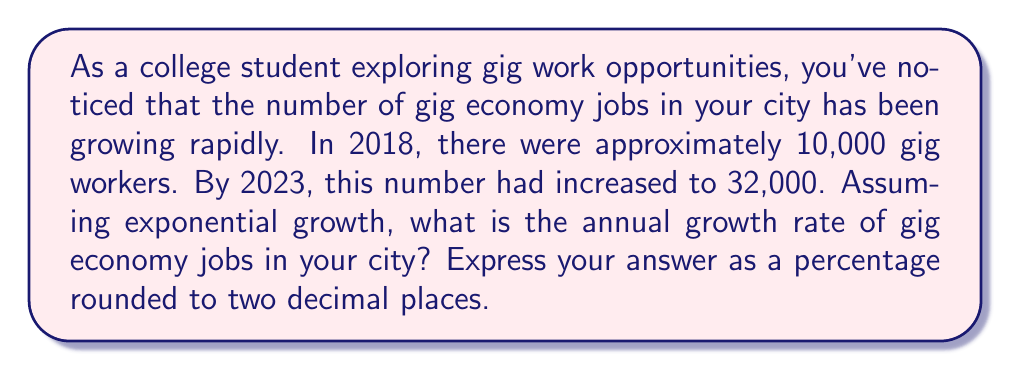Could you help me with this problem? To solve this problem, we'll use the exponential growth formula:

$$A = P(1 + r)^t$$

Where:
$A$ = Final amount (32,000 gig workers in 2023)
$P$ = Initial amount (10,000 gig workers in 2018)
$r$ = Annual growth rate (what we're solving for)
$t$ = Time period (5 years from 2018 to 2023)

Let's plug in the known values:

$$32,000 = 10,000(1 + r)^5$$

Now, let's solve for $r$:

1) Divide both sides by 10,000:
   $$3.2 = (1 + r)^5$$

2) Take the 5th root of both sides:
   $$\sqrt[5]{3.2} = 1 + r$$

3) Subtract 1 from both sides:
   $$\sqrt[5]{3.2} - 1 = r$$

4) Calculate the value:
   $$r \approx 1.2615 - 1 = 0.2615$$

5) Convert to a percentage:
   $$r \approx 0.2615 \times 100\% = 26.15\%$$

Therefore, the annual growth rate of gig economy jobs in your city is approximately 26.15%.
Answer: 26.15% 